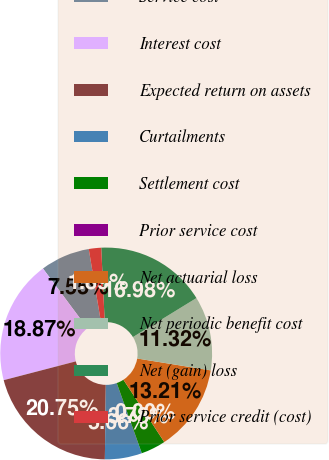Convert chart. <chart><loc_0><loc_0><loc_500><loc_500><pie_chart><fcel>Service cost<fcel>Interest cost<fcel>Expected return on assets<fcel>Curtailments<fcel>Settlement cost<fcel>Prior service cost<fcel>Net actuarial loss<fcel>Net periodic benefit cost<fcel>Net (gain) loss<fcel>Prior service credit (cost)<nl><fcel>7.55%<fcel>18.87%<fcel>20.75%<fcel>5.66%<fcel>3.78%<fcel>0.0%<fcel>13.21%<fcel>11.32%<fcel>16.98%<fcel>1.89%<nl></chart> 